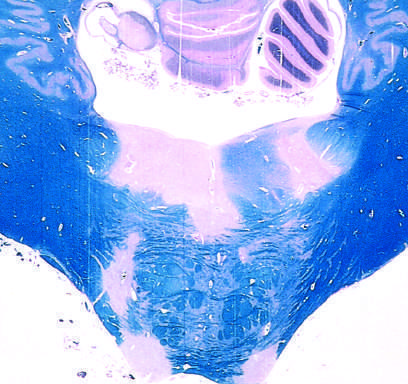what stain for myelin?
Answer the question using a single word or phrase. Luxol fast blue-periodic acid-schiff 